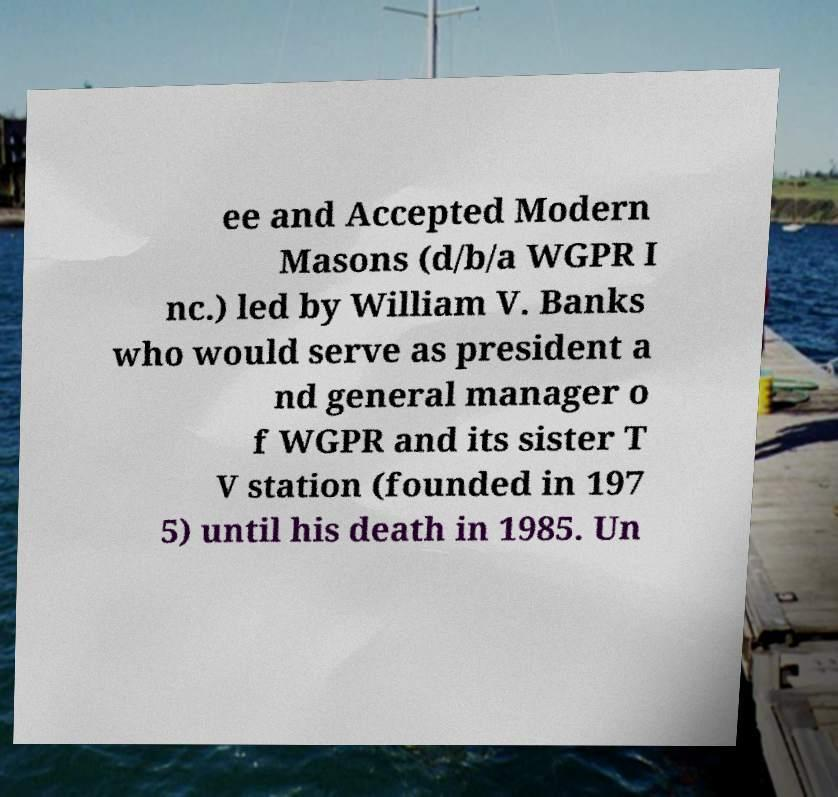There's text embedded in this image that I need extracted. Can you transcribe it verbatim? ee and Accepted Modern Masons (d/b/a WGPR I nc.) led by William V. Banks who would serve as president a nd general manager o f WGPR and its sister T V station (founded in 197 5) until his death in 1985. Un 